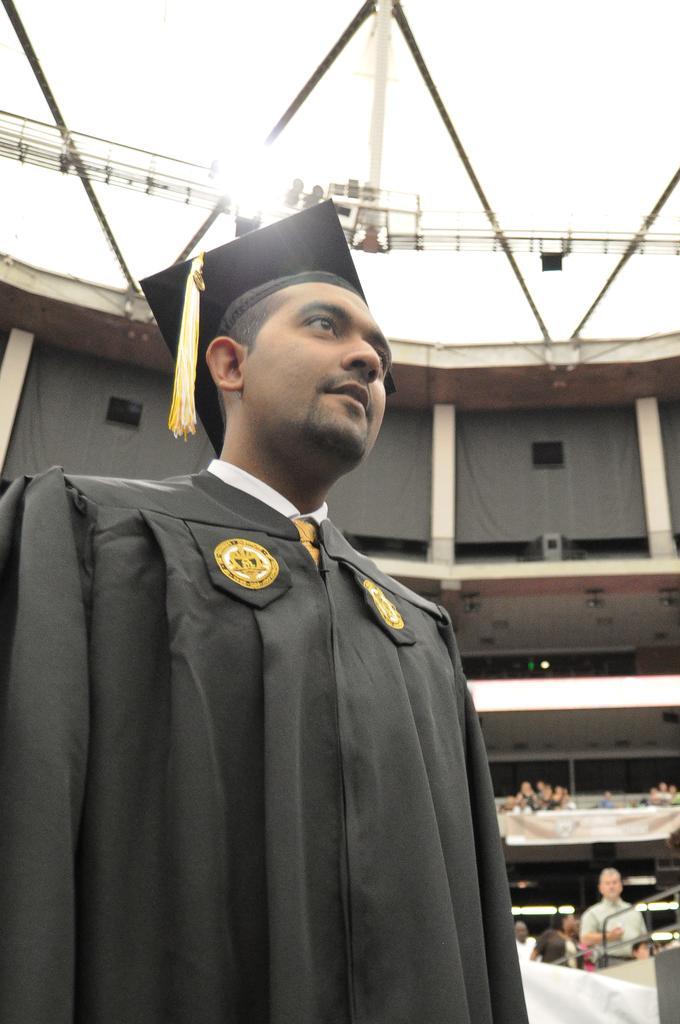Describe this image in one or two sentences. In this image there is a person wearing a graduation dress and a hat, behind the person there is a building. 